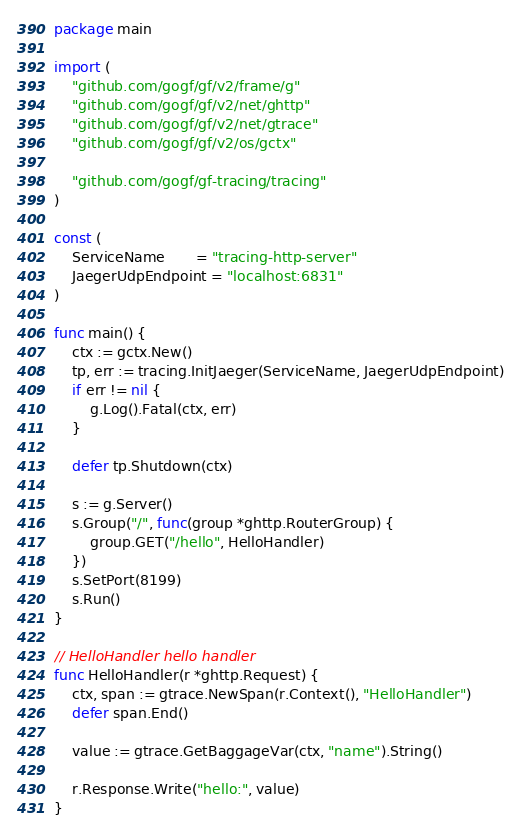<code> <loc_0><loc_0><loc_500><loc_500><_Go_>package main

import (
	"github.com/gogf/gf/v2/frame/g"
	"github.com/gogf/gf/v2/net/ghttp"
	"github.com/gogf/gf/v2/net/gtrace"
	"github.com/gogf/gf/v2/os/gctx"

	"github.com/gogf/gf-tracing/tracing"
)

const (
	ServiceName       = "tracing-http-server"
	JaegerUdpEndpoint = "localhost:6831"
)

func main() {
	ctx := gctx.New()
	tp, err := tracing.InitJaeger(ServiceName, JaegerUdpEndpoint)
	if err != nil {
		g.Log().Fatal(ctx, err)
	}

	defer tp.Shutdown(ctx)

	s := g.Server()
	s.Group("/", func(group *ghttp.RouterGroup) {
		group.GET("/hello", HelloHandler)
	})
	s.SetPort(8199)
	s.Run()
}

// HelloHandler hello handler
func HelloHandler(r *ghttp.Request) {
	ctx, span := gtrace.NewSpan(r.Context(), "HelloHandler")
	defer span.End()

	value := gtrace.GetBaggageVar(ctx, "name").String()

	r.Response.Write("hello:", value)
}
</code> 